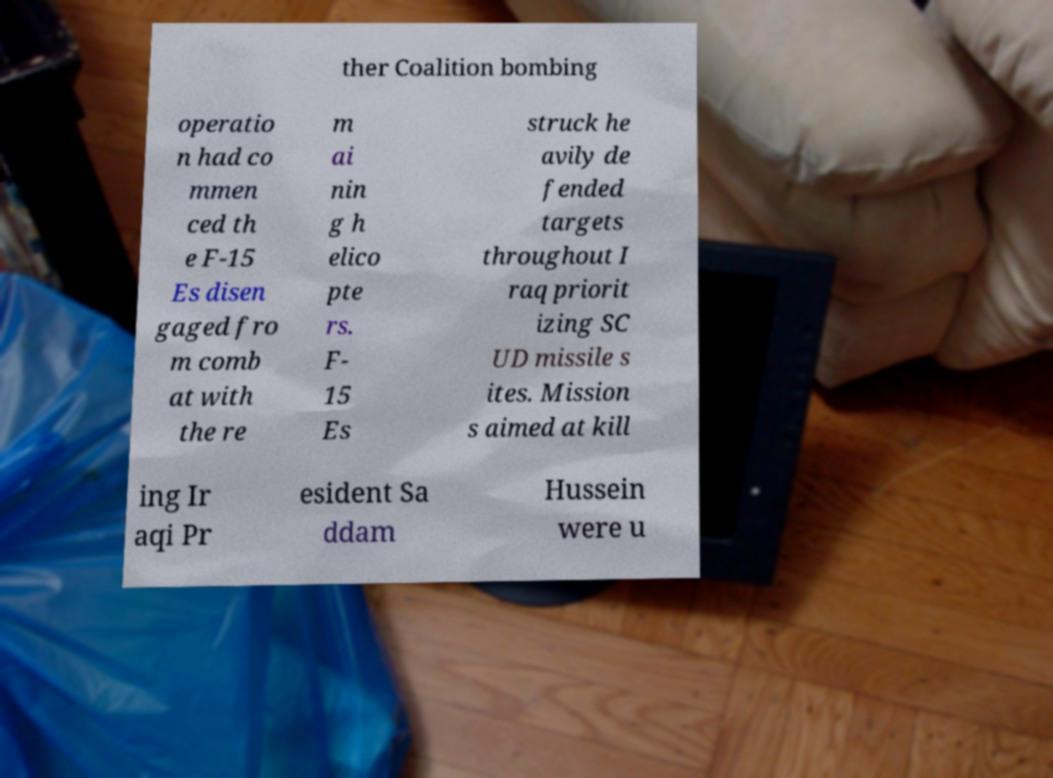Can you accurately transcribe the text from the provided image for me? ther Coalition bombing operatio n had co mmen ced th e F-15 Es disen gaged fro m comb at with the re m ai nin g h elico pte rs. F- 15 Es struck he avily de fended targets throughout I raq priorit izing SC UD missile s ites. Mission s aimed at kill ing Ir aqi Pr esident Sa ddam Hussein were u 